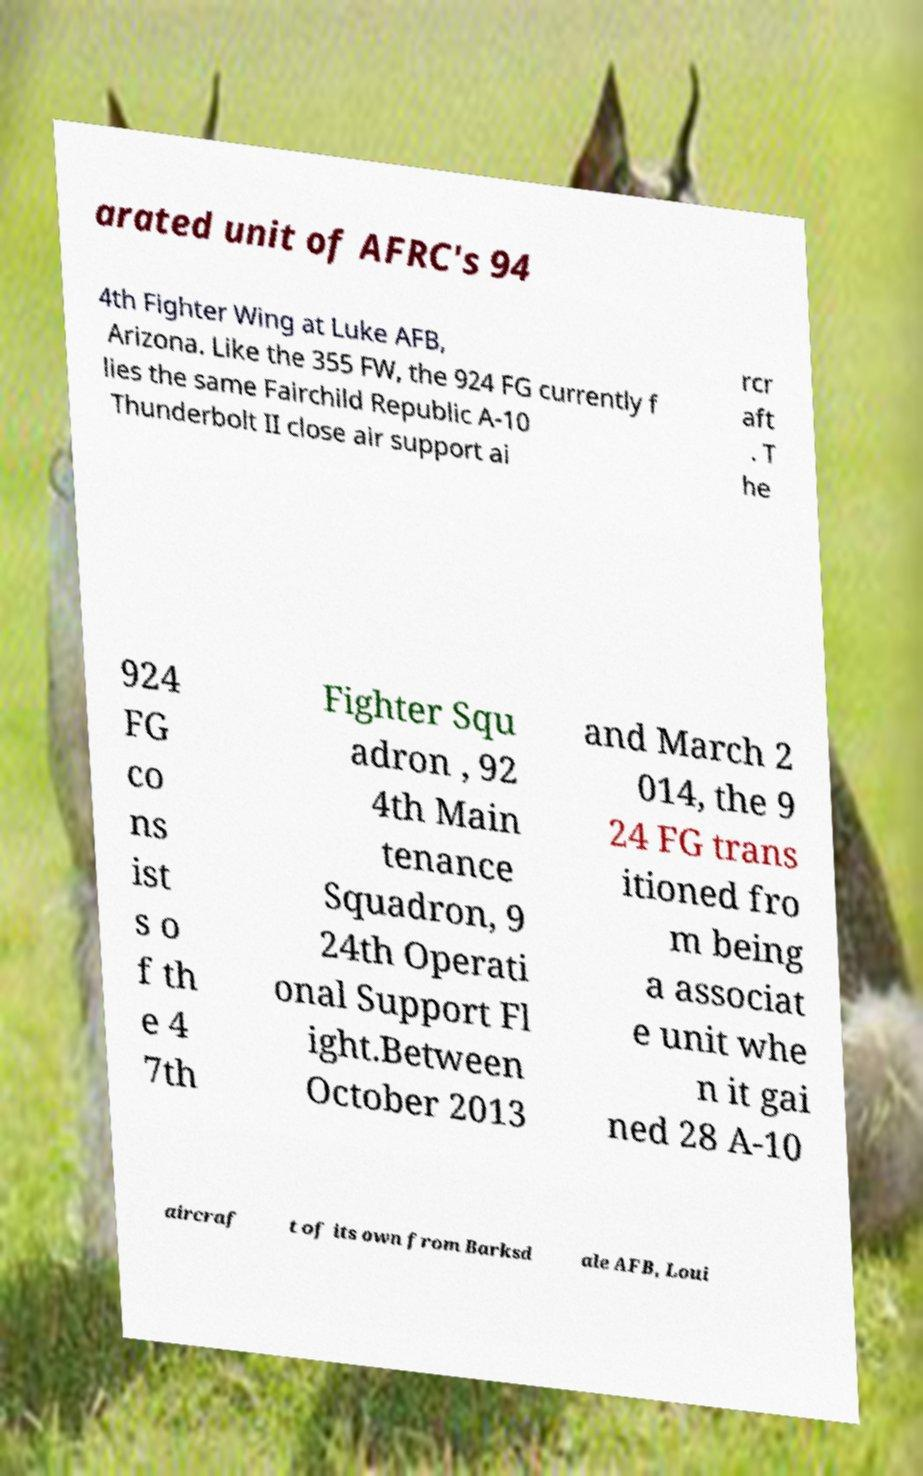Can you read and provide the text displayed in the image?This photo seems to have some interesting text. Can you extract and type it out for me? arated unit of AFRC's 94 4th Fighter Wing at Luke AFB, Arizona. Like the 355 FW, the 924 FG currently f lies the same Fairchild Republic A-10 Thunderbolt II close air support ai rcr aft . T he 924 FG co ns ist s o f th e 4 7th Fighter Squ adron , 92 4th Main tenance Squadron, 9 24th Operati onal Support Fl ight.Between October 2013 and March 2 014, the 9 24 FG trans itioned fro m being a associat e unit whe n it gai ned 28 A-10 aircraf t of its own from Barksd ale AFB, Loui 